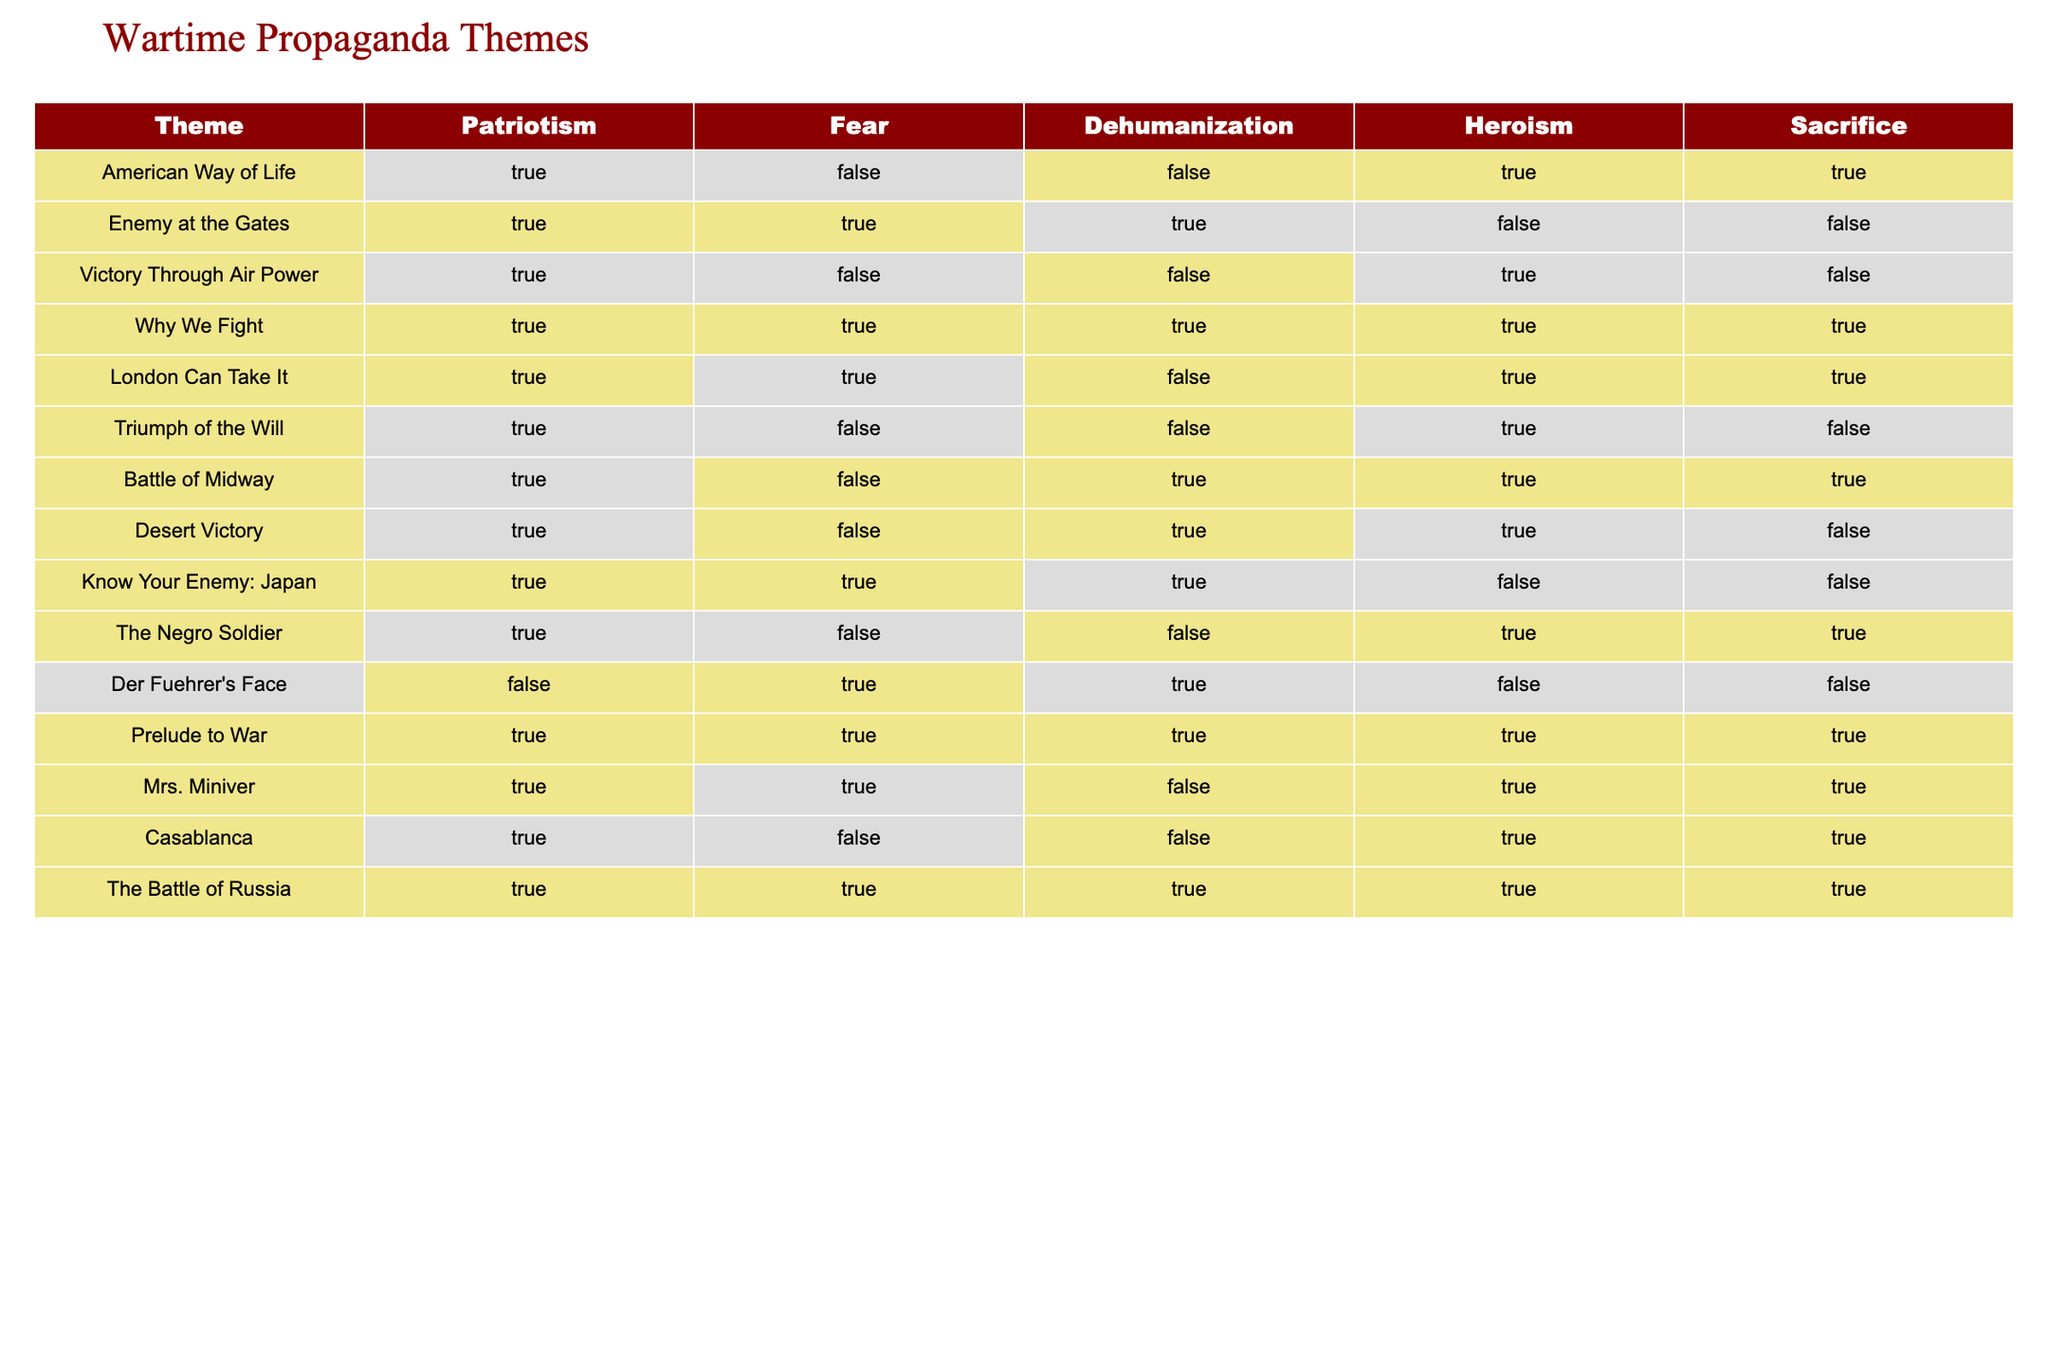What theme includes the concepts of sacrifice and heroism but not fear? By examining the table, we look for rows where both "Sacrifice" and "Heroism" are marked as TRUE while "Fear" is marked as FALSE. The row "Victory Through Air Power" matches these criteria.
Answer: Victory Through Air Power Is "The Battle of Russia" associated with dehumanization? In the row for "The Battle of Russia," the "Dehumanization" column shows TRUE. Thus, this theme is associated with dehumanization.
Answer: Yes Which themes emphasize both patriotism and fear? To answer this, we need to identify rows where both "Patriotism" and "Fear" are marked as TRUE. The themes "Enemy at the Gates," "Why We Fight," "London Can Take It," "The Battle of Russia," and "Prelude to War" have both marked as TRUE.
Answer: Enemy at the Gates, Why We Fight, London Can Take It, The Battle of Russia, Prelude to War How many themes portray heroism while neglecting to highlight sacrifice? We check for rows where "Heroism" is TRUE and "Sacrifice" is FALSE. The rows "Enemy at the Gates," "Know Your Enemy: Japan," and "Der Fuehrer's Face" meet these conditions. Therefore, there are three themes.
Answer: 3 What is the total number of themes that depict both patriotism and dehumanization? We look for rows where both "Patriotism" and "Dehumanization" are TRUE. The themes are "Enemy at the Gates," "Know Your Enemy: Japan," and "The Battle of Midway." Hence, there are three themes that fit this description.
Answer: 3 